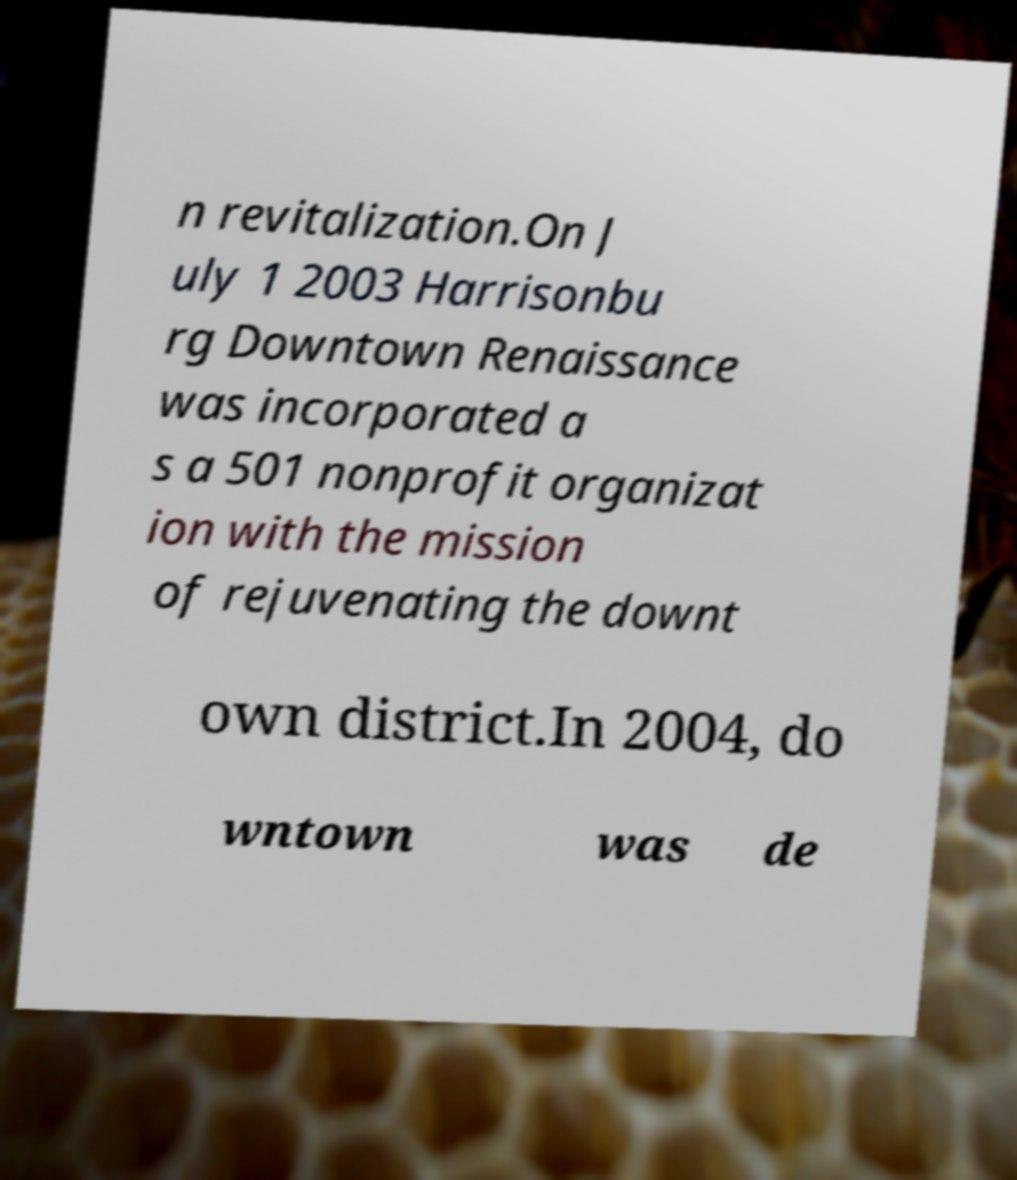There's text embedded in this image that I need extracted. Can you transcribe it verbatim? n revitalization.On J uly 1 2003 Harrisonbu rg Downtown Renaissance was incorporated a s a 501 nonprofit organizat ion with the mission of rejuvenating the downt own district.In 2004, do wntown was de 